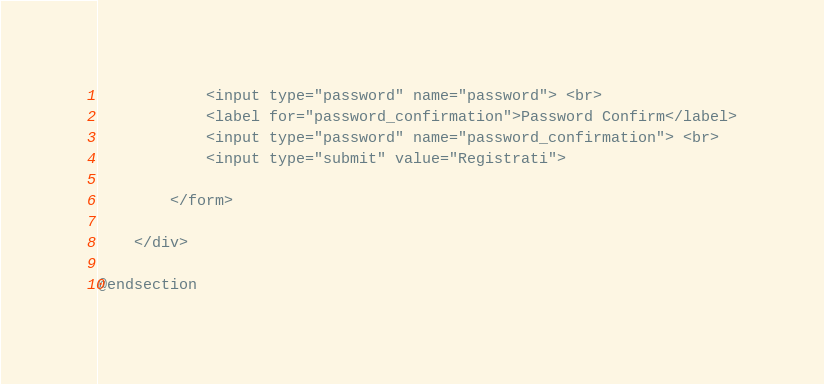Convert code to text. <code><loc_0><loc_0><loc_500><loc_500><_PHP_>            <input type="password" name="password"> <br>
            <label for="password_confirmation">Password Confirm</label>
            <input type="password" name="password_confirmation"> <br>
            <input type="submit" value="Registrati">
            
        </form>

    </div>
    
@endsection</code> 